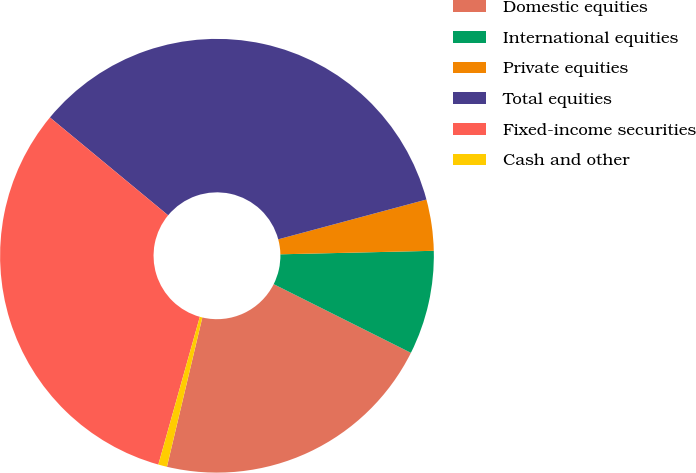Convert chart to OTSL. <chart><loc_0><loc_0><loc_500><loc_500><pie_chart><fcel>Domestic equities<fcel>International equities<fcel>Private equities<fcel>Total equities<fcel>Fixed-income securities<fcel>Cash and other<nl><fcel>21.32%<fcel>7.75%<fcel>3.81%<fcel>34.82%<fcel>31.65%<fcel>0.65%<nl></chart> 